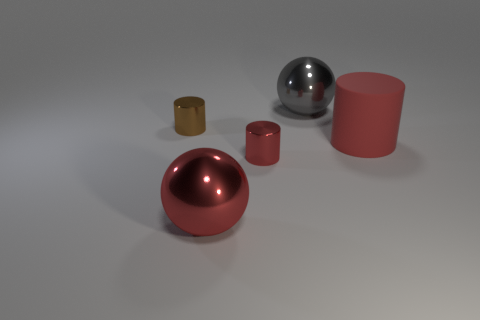Add 4 small brown rubber spheres. How many objects exist? 9 Subtract all cylinders. How many objects are left? 2 Subtract all small red objects. Subtract all big red rubber things. How many objects are left? 3 Add 4 gray things. How many gray things are left? 5 Add 3 gray matte objects. How many gray matte objects exist? 3 Subtract 1 brown cylinders. How many objects are left? 4 